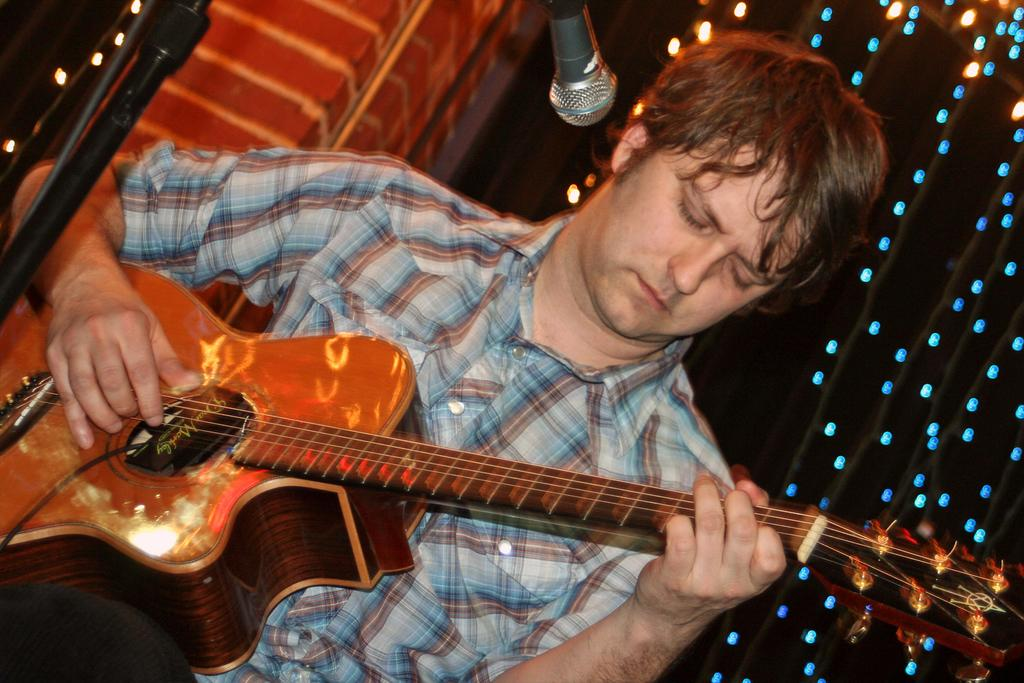What is the main subject of the image? The main subject of the image is a man sitting in the middle. What is the man holding in the image? The man is holding a yellow-colored music instrument. What is the man doing in the image? The man is singing. What can be seen near the man in the image? There is a black-colored microphone in the image. Is there a kettle boiling water in the image? No, there is no kettle or boiling water present in the image. What type of heat source is used to heat the spring in the image? There is no spring or heat source present in the image. 